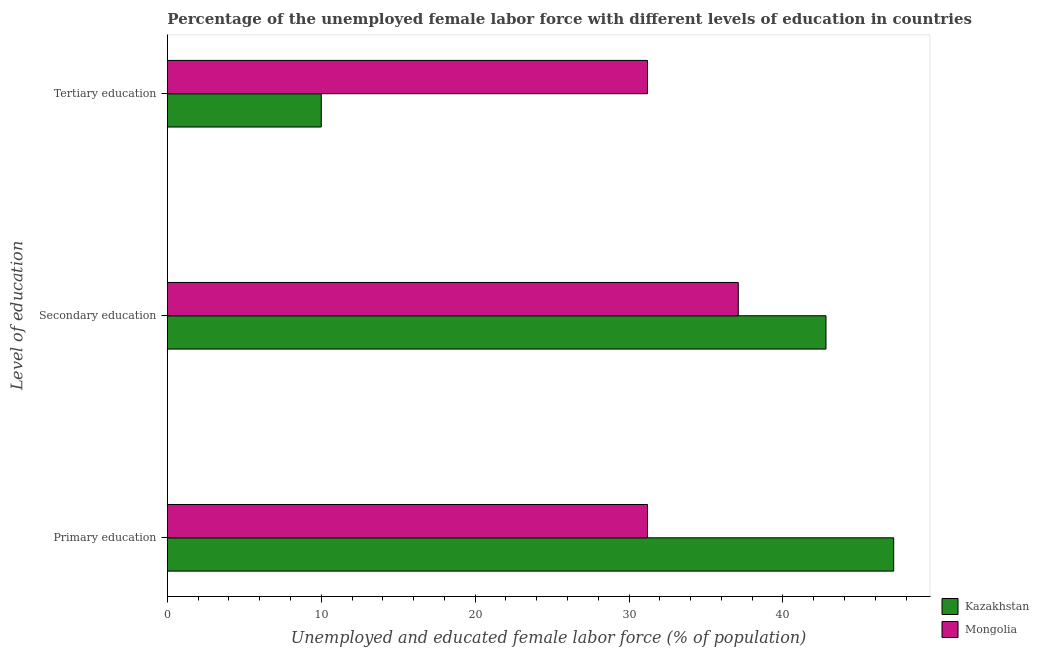How many groups of bars are there?
Give a very brief answer. 3. Are the number of bars per tick equal to the number of legend labels?
Ensure brevity in your answer.  Yes. Are the number of bars on each tick of the Y-axis equal?
Your response must be concise. Yes. How many bars are there on the 2nd tick from the top?
Your answer should be very brief. 2. What is the label of the 2nd group of bars from the top?
Provide a succinct answer. Secondary education. What is the percentage of female labor force who received tertiary education in Mongolia?
Offer a terse response. 31.2. Across all countries, what is the maximum percentage of female labor force who received primary education?
Offer a terse response. 47.2. Across all countries, what is the minimum percentage of female labor force who received primary education?
Provide a succinct answer. 31.2. In which country was the percentage of female labor force who received tertiary education maximum?
Your answer should be compact. Mongolia. In which country was the percentage of female labor force who received tertiary education minimum?
Your answer should be compact. Kazakhstan. What is the total percentage of female labor force who received tertiary education in the graph?
Ensure brevity in your answer.  41.2. What is the difference between the percentage of female labor force who received tertiary education in Kazakhstan and that in Mongolia?
Provide a succinct answer. -21.2. What is the difference between the percentage of female labor force who received primary education in Mongolia and the percentage of female labor force who received tertiary education in Kazakhstan?
Make the answer very short. 21.2. What is the average percentage of female labor force who received tertiary education per country?
Provide a short and direct response. 20.6. What is the difference between the percentage of female labor force who received primary education and percentage of female labor force who received secondary education in Kazakhstan?
Provide a short and direct response. 4.4. What is the ratio of the percentage of female labor force who received tertiary education in Mongolia to that in Kazakhstan?
Make the answer very short. 3.12. Is the percentage of female labor force who received secondary education in Kazakhstan less than that in Mongolia?
Make the answer very short. No. Is the difference between the percentage of female labor force who received tertiary education in Mongolia and Kazakhstan greater than the difference between the percentage of female labor force who received secondary education in Mongolia and Kazakhstan?
Offer a terse response. Yes. What is the difference between the highest and the second highest percentage of female labor force who received secondary education?
Make the answer very short. 5.7. What is the difference between the highest and the lowest percentage of female labor force who received primary education?
Make the answer very short. 16. What does the 2nd bar from the top in Tertiary education represents?
Provide a succinct answer. Kazakhstan. What does the 1st bar from the bottom in Primary education represents?
Ensure brevity in your answer.  Kazakhstan. How many countries are there in the graph?
Offer a terse response. 2. What is the difference between two consecutive major ticks on the X-axis?
Your answer should be compact. 10. Are the values on the major ticks of X-axis written in scientific E-notation?
Offer a very short reply. No. How many legend labels are there?
Offer a very short reply. 2. How are the legend labels stacked?
Make the answer very short. Vertical. What is the title of the graph?
Provide a succinct answer. Percentage of the unemployed female labor force with different levels of education in countries. Does "Pacific island small states" appear as one of the legend labels in the graph?
Provide a short and direct response. No. What is the label or title of the X-axis?
Give a very brief answer. Unemployed and educated female labor force (% of population). What is the label or title of the Y-axis?
Your response must be concise. Level of education. What is the Unemployed and educated female labor force (% of population) in Kazakhstan in Primary education?
Keep it short and to the point. 47.2. What is the Unemployed and educated female labor force (% of population) in Mongolia in Primary education?
Offer a very short reply. 31.2. What is the Unemployed and educated female labor force (% of population) of Kazakhstan in Secondary education?
Provide a short and direct response. 42.8. What is the Unemployed and educated female labor force (% of population) in Mongolia in Secondary education?
Keep it short and to the point. 37.1. What is the Unemployed and educated female labor force (% of population) of Mongolia in Tertiary education?
Offer a very short reply. 31.2. Across all Level of education, what is the maximum Unemployed and educated female labor force (% of population) in Kazakhstan?
Offer a terse response. 47.2. Across all Level of education, what is the maximum Unemployed and educated female labor force (% of population) in Mongolia?
Provide a short and direct response. 37.1. Across all Level of education, what is the minimum Unemployed and educated female labor force (% of population) in Kazakhstan?
Offer a terse response. 10. Across all Level of education, what is the minimum Unemployed and educated female labor force (% of population) of Mongolia?
Ensure brevity in your answer.  31.2. What is the total Unemployed and educated female labor force (% of population) in Mongolia in the graph?
Keep it short and to the point. 99.5. What is the difference between the Unemployed and educated female labor force (% of population) in Mongolia in Primary education and that in Secondary education?
Provide a short and direct response. -5.9. What is the difference between the Unemployed and educated female labor force (% of population) of Kazakhstan in Primary education and that in Tertiary education?
Offer a very short reply. 37.2. What is the difference between the Unemployed and educated female labor force (% of population) in Mongolia in Primary education and that in Tertiary education?
Your response must be concise. 0. What is the difference between the Unemployed and educated female labor force (% of population) of Kazakhstan in Secondary education and that in Tertiary education?
Make the answer very short. 32.8. What is the difference between the Unemployed and educated female labor force (% of population) of Mongolia in Secondary education and that in Tertiary education?
Your response must be concise. 5.9. What is the difference between the Unemployed and educated female labor force (% of population) in Kazakhstan in Secondary education and the Unemployed and educated female labor force (% of population) in Mongolia in Tertiary education?
Offer a terse response. 11.6. What is the average Unemployed and educated female labor force (% of population) of Kazakhstan per Level of education?
Provide a succinct answer. 33.33. What is the average Unemployed and educated female labor force (% of population) of Mongolia per Level of education?
Provide a succinct answer. 33.17. What is the difference between the Unemployed and educated female labor force (% of population) of Kazakhstan and Unemployed and educated female labor force (% of population) of Mongolia in Primary education?
Your response must be concise. 16. What is the difference between the Unemployed and educated female labor force (% of population) in Kazakhstan and Unemployed and educated female labor force (% of population) in Mongolia in Tertiary education?
Your answer should be compact. -21.2. What is the ratio of the Unemployed and educated female labor force (% of population) in Kazakhstan in Primary education to that in Secondary education?
Your response must be concise. 1.1. What is the ratio of the Unemployed and educated female labor force (% of population) in Mongolia in Primary education to that in Secondary education?
Ensure brevity in your answer.  0.84. What is the ratio of the Unemployed and educated female labor force (% of population) in Kazakhstan in Primary education to that in Tertiary education?
Your answer should be compact. 4.72. What is the ratio of the Unemployed and educated female labor force (% of population) in Kazakhstan in Secondary education to that in Tertiary education?
Your answer should be compact. 4.28. What is the ratio of the Unemployed and educated female labor force (% of population) in Mongolia in Secondary education to that in Tertiary education?
Your answer should be very brief. 1.19. What is the difference between the highest and the lowest Unemployed and educated female labor force (% of population) in Kazakhstan?
Your answer should be compact. 37.2. What is the difference between the highest and the lowest Unemployed and educated female labor force (% of population) in Mongolia?
Keep it short and to the point. 5.9. 